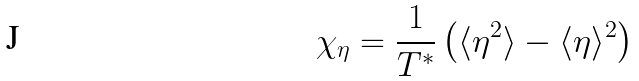Convert formula to latex. <formula><loc_0><loc_0><loc_500><loc_500>\chi _ { \eta } = \frac { 1 } { T ^ { * } } \left ( \langle \eta ^ { 2 } \rangle - \langle \eta \rangle ^ { 2 } \right )</formula> 